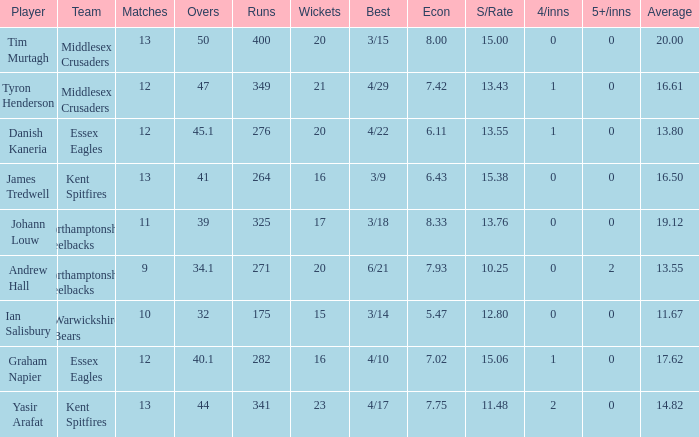Name the least matches for runs being 276 12.0. 